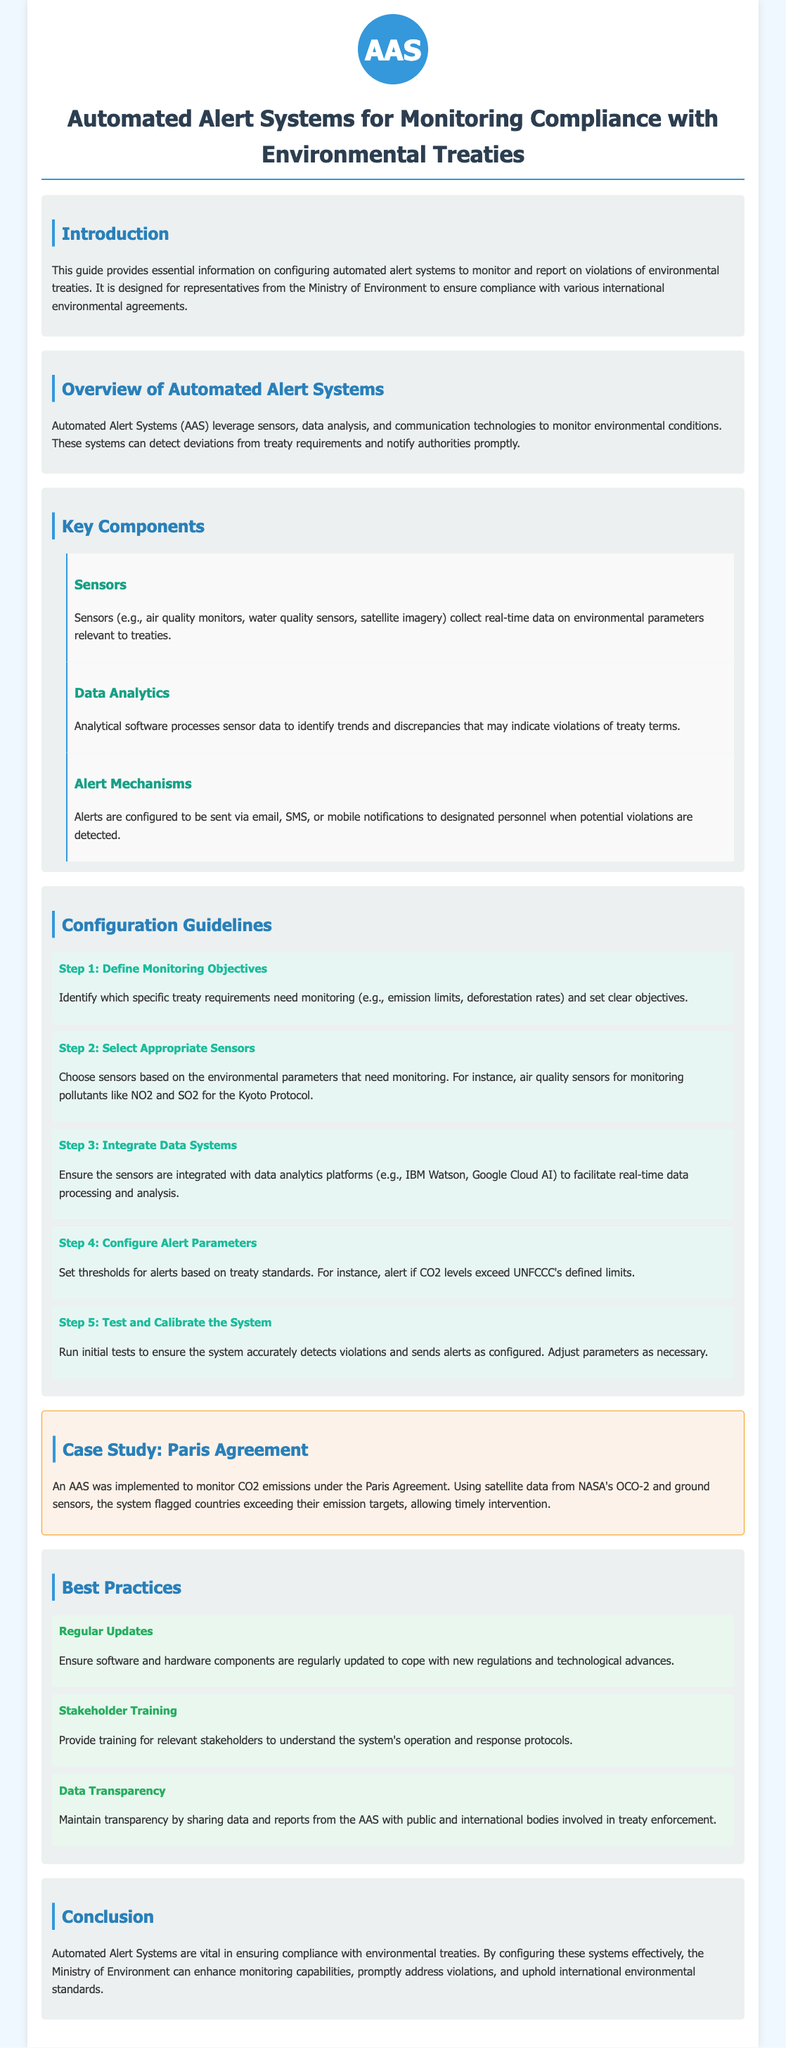What is the title of the guide? The title is located at the top of the document and indicates its focus on automated alert systems in environmental treaty compliance.
Answer: Automated Alert Systems for Monitoring Compliance with Environmental Treaties What is the purpose of this guide? The purpose is outlined in the introduction and highlights the importance of monitoring treaty compliance.
Answer: Configuring automated alert systems to monitor and report on violations of environmental treaties What are the key components of Automated Alert Systems? The document lists three key components: sensors, data analytics, and alert mechanisms.
Answer: Sensors, Data Analytics, Alert Mechanisms What is the first step in the configuration guidelines? The first step is specified in the configuration guidelines section and involves establishing clear monitoring objectives.
Answer: Define Monitoring Objectives What type of sensors is mentioned for monitoring pollutants? The document refers to specific types of sensors suitable for monitoring the environmental parameters of treaties.
Answer: Air quality sensors How is data processed in Automated Alert Systems? The document explains that analytical software processes the sensor data to identify trends and discrepancies.
Answer: Data Analytics What is one best practice mentioned in the guide? The guide provides a list of best practices and one item focused on ensuring updated components.
Answer: Regular Updates What is an example of a case study provided in the document? The case study illustrates a practical application of the system in monitoring CO2 emissions under a specific treaty.
Answer: Paris Agreement 